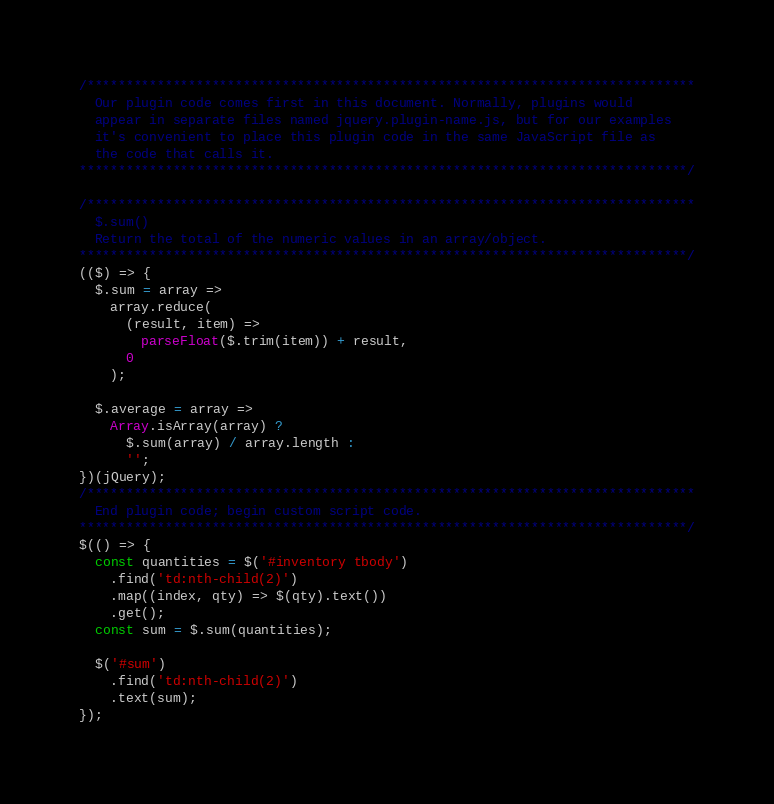Convert code to text. <code><loc_0><loc_0><loc_500><loc_500><_JavaScript_>/******************************************************************************
  Our plugin code comes first in this document. Normally, plugins would
  appear in separate files named jquery.plugin-name.js, but for our examples
  it's convenient to place this plugin code in the same JavaScript file as
  the code that calls it.
******************************************************************************/

/******************************************************************************
  $.sum()
  Return the total of the numeric values in an array/object.
******************************************************************************/
(($) => {
  $.sum = array =>
    array.reduce(
      (result, item) =>
        parseFloat($.trim(item)) + result,
      0
    );

  $.average = array =>
    Array.isArray(array) ?
      $.sum(array) / array.length :
      '';
})(jQuery);
/******************************************************************************
  End plugin code; begin custom script code.
******************************************************************************/
$(() => {
  const quantities = $('#inventory tbody')
    .find('td:nth-child(2)')
    .map((index, qty) => $(qty).text())
    .get();
  const sum = $.sum(quantities);

  $('#sum')
    .find('td:nth-child(2)')
    .text(sum);
});
</code> 